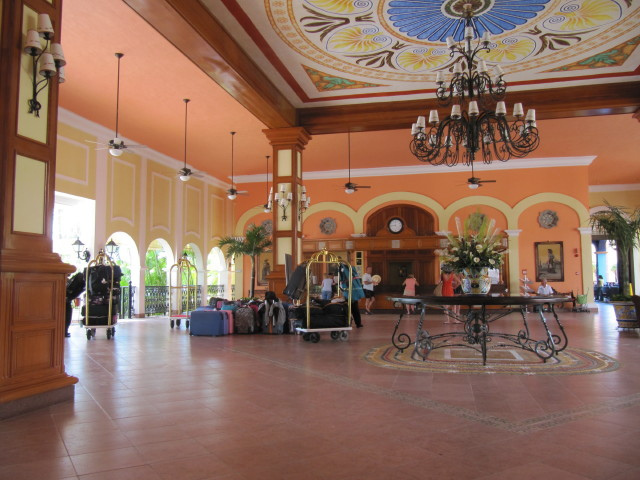<image>What is the style of artwork on the ceiling called? I am not sure about the style of artwork on the ceiling. It can be called a mural or a mosaic. What is the style of artwork on the ceiling called? I am not sure what the style of artwork on the ceiling is called. It can be seen as a mural or a mosaic. 